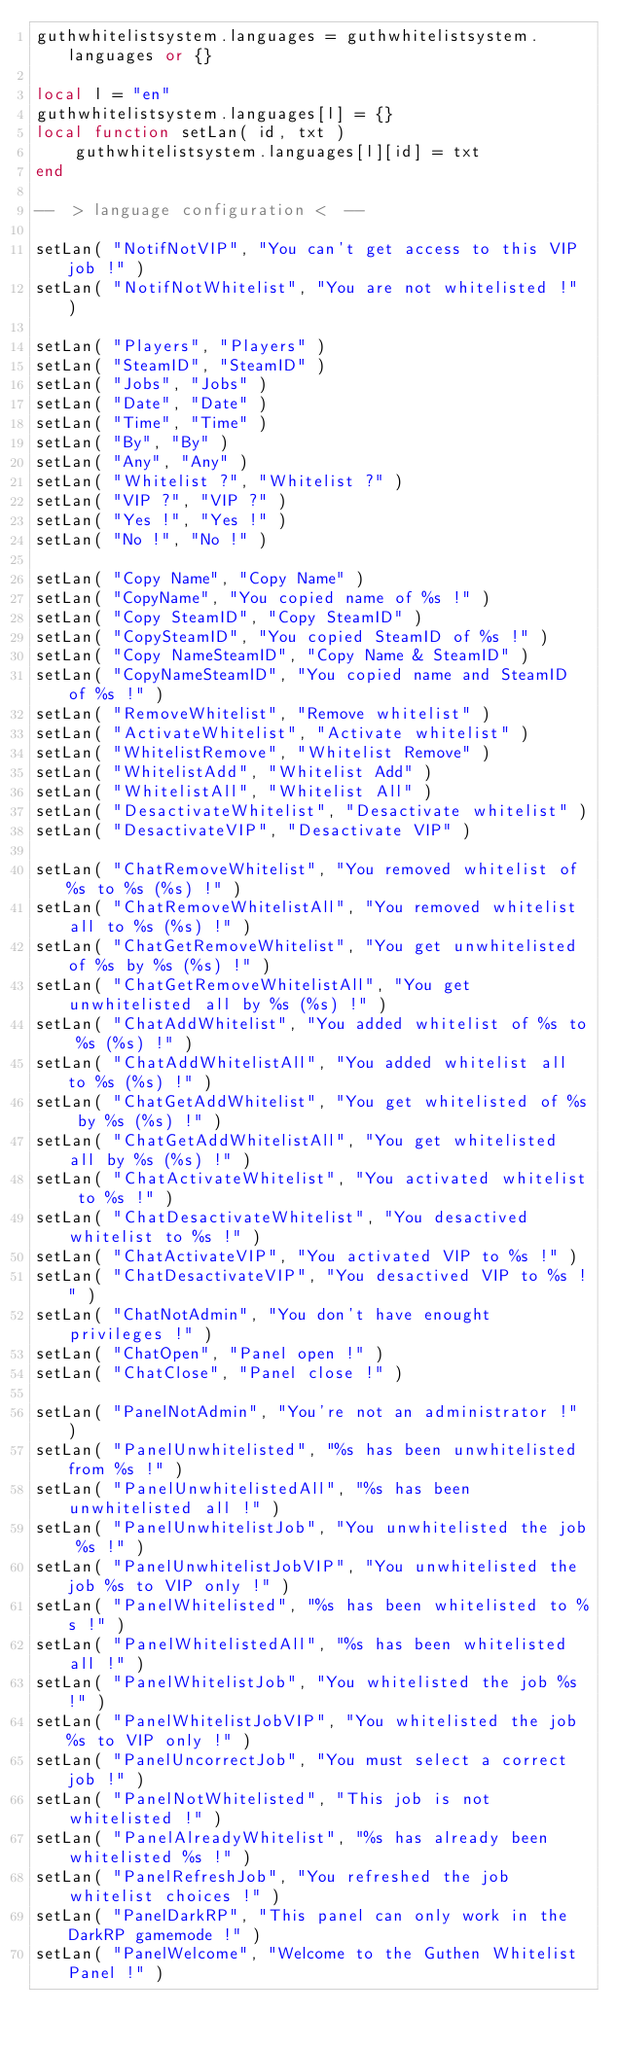Convert code to text. <code><loc_0><loc_0><loc_500><loc_500><_Lua_>guthwhitelistsystem.languages = guthwhitelistsystem.languages or {}

local l = "en"
guthwhitelistsystem.languages[l] = {}
local function setLan( id, txt )
    guthwhitelistsystem.languages[l][id] = txt
end

--  > language configuration <  --

setLan( "NotifNotVIP", "You can't get access to this VIP job !" )
setLan( "NotifNotWhitelist", "You are not whitelisted !" )

setLan( "Players", "Players" )
setLan( "SteamID", "SteamID" )
setLan( "Jobs", "Jobs" )
setLan( "Date", "Date" )
setLan( "Time", "Time" )
setLan( "By", "By" )
setLan( "Any", "Any" )
setLan( "Whitelist ?", "Whitelist ?" )
setLan( "VIP ?", "VIP ?" )
setLan( "Yes !", "Yes !" )
setLan( "No !", "No !" )

setLan( "Copy Name", "Copy Name" )
setLan( "CopyName", "You copied name of %s !" )
setLan( "Copy SteamID", "Copy SteamID" )
setLan( "CopySteamID", "You copied SteamID of %s !" )
setLan( "Copy NameSteamID", "Copy Name & SteamID" )
setLan( "CopyNameSteamID", "You copied name and SteamID of %s !" )
setLan( "RemoveWhitelist", "Remove whitelist" )
setLan( "ActivateWhitelist", "Activate whitelist" )
setLan( "WhitelistRemove", "Whitelist Remove" )
setLan( "WhitelistAdd", "Whitelist Add" )
setLan( "WhitelistAll", "Whitelist All" )
setLan( "DesactivateWhitelist", "Desactivate whitelist" )
setLan( "DesactivateVIP", "Desactivate VIP" )

setLan( "ChatRemoveWhitelist", "You removed whitelist of %s to %s (%s) !" )
setLan( "ChatRemoveWhitelistAll", "You removed whitelist all to %s (%s) !" )
setLan( "ChatGetRemoveWhitelist", "You get unwhitelisted of %s by %s (%s) !" )
setLan( "ChatGetRemoveWhitelistAll", "You get unwhitelisted all by %s (%s) !" )
setLan( "ChatAddWhitelist", "You added whitelist of %s to %s (%s) !" )
setLan( "ChatAddWhitelistAll", "You added whitelist all to %s (%s) !" )
setLan( "ChatGetAddWhitelist", "You get whitelisted of %s by %s (%s) !" )
setLan( "ChatGetAddWhitelistAll", "You get whitelisted all by %s (%s) !" )
setLan( "ChatActivateWhitelist", "You activated whitelist to %s !" )
setLan( "ChatDesactivateWhitelist", "You desactived whitelist to %s !" )
setLan( "ChatActivateVIP", "You activated VIP to %s !" )
setLan( "ChatDesactivateVIP", "You desactived VIP to %s !" )
setLan( "ChatNotAdmin", "You don't have enought privileges !" )
setLan( "ChatOpen", "Panel open !" )
setLan( "ChatClose", "Panel close !" )

setLan( "PanelNotAdmin", "You're not an administrator !" )
setLan( "PanelUnwhitelisted", "%s has been unwhitelisted from %s !" )
setLan( "PanelUnwhitelistedAll", "%s has been unwhitelisted all !" )
setLan( "PanelUnwhitelistJob", "You unwhitelisted the job %s !" )
setLan( "PanelUnwhitelistJobVIP", "You unwhitelisted the job %s to VIP only !" )
setLan( "PanelWhitelisted", "%s has been whitelisted to %s !" )
setLan( "PanelWhitelistedAll", "%s has been whitelisted all !" )
setLan( "PanelWhitelistJob", "You whitelisted the job %s !" )
setLan( "PanelWhitelistJobVIP", "You whitelisted the job %s to VIP only !" )
setLan( "PanelUncorrectJob", "You must select a correct job !" )
setLan( "PanelNotWhitelisted", "This job is not whitelisted !" )
setLan( "PanelAlreadyWhitelist", "%s has already been whitelisted %s !" )
setLan( "PanelRefreshJob", "You refreshed the job whitelist choices !" )
setLan( "PanelDarkRP", "This panel can only work in the DarkRP gamemode !" )
setLan( "PanelWelcome", "Welcome to the Guthen Whitelist Panel !" )
</code> 